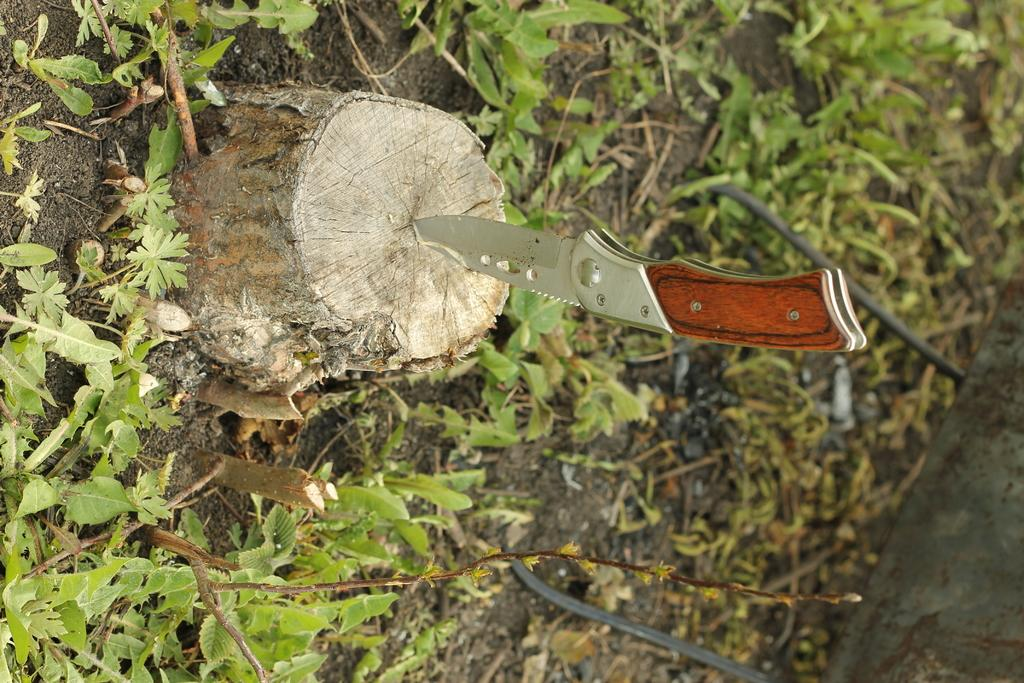What object is penetrated into a log of wood in the image? There is a knife in the image that is penetrated into a log of wood. What can be seen in the background of the image? There is ground and plants visible in the background of the image. What type of prison can be seen in the image? There is no prison present in the image; it features a knife penetrated into a log of wood and a background with ground and plants. How does the knife affect the stomach in the image? There is no stomach present in the image, and the knife is penetrated into a log of wood, not a stomach. 